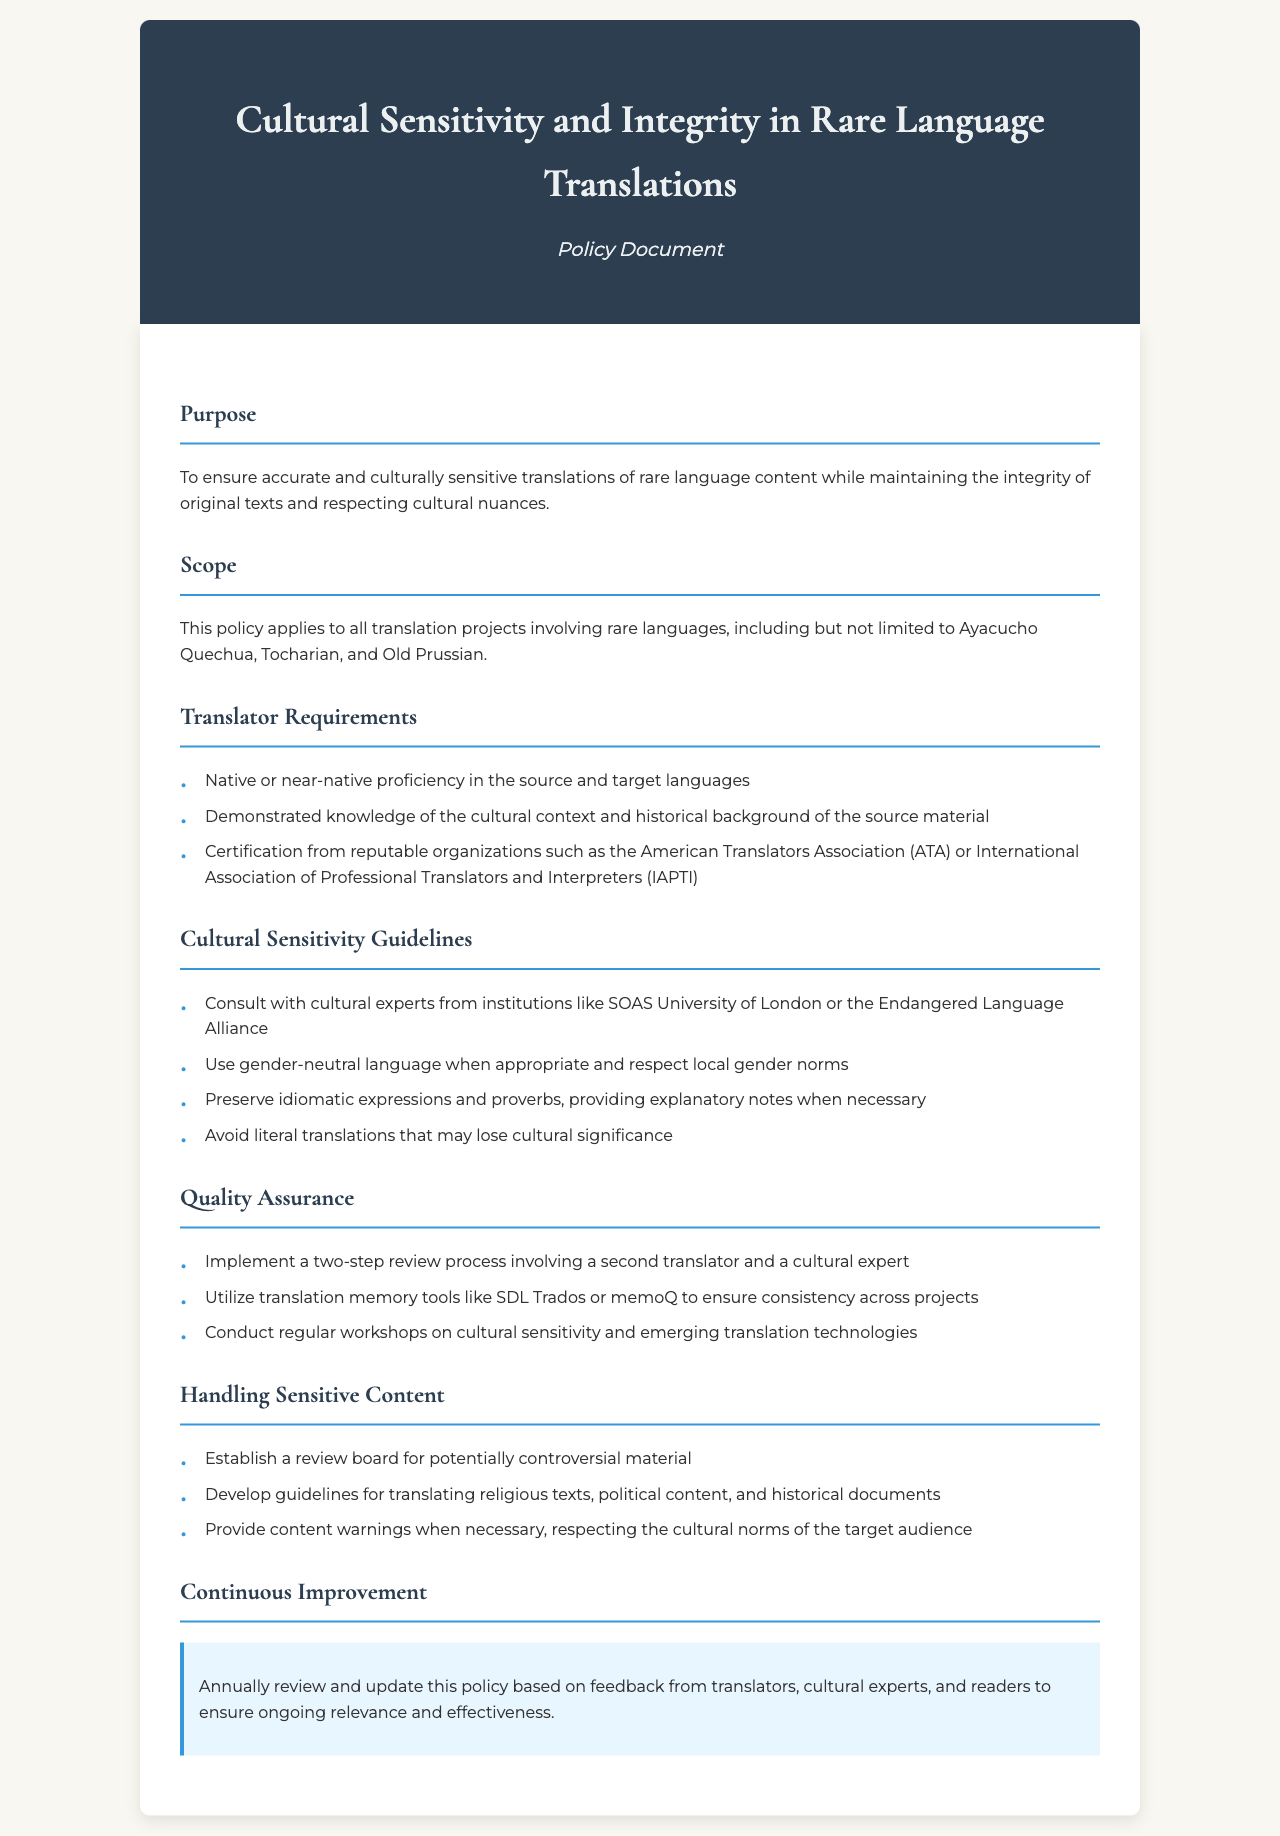What is the purpose of the policy? The purpose is to ensure accurate and culturally sensitive translations of rare language content while maintaining the integrity of original texts and respecting cultural nuances.
Answer: Ensuring accurate translations Which rare languages are mentioned in the scope? The scope mentions specific rare languages relevant to the policy, including Ayacucho Quechua, Tocharian, and Old Prussian.
Answer: Ayacucho Quechua, Tocharian, Old Prussian What type of proficiency is required for translators? The policy outlines a requirement for translators to have a certain level of language proficiency for effective translation.
Answer: Native or near-native proficiency What should translators consult for cultural sensitivity? The document specifies consulting specific institutions or experts to enhance understanding of cultural contexts.
Answer: Cultural experts How many steps are in the quality assurance process? The policy describes a review process composed of multiple steps to ensure high-quality translations.
Answer: Two-step What is a guideline for handling sensitive content? A guideline listed in the document addresses the consideration of various types of sensitive material in translations.
Answer: Establish a review board What is required annually for the policy? The document highlights an ongoing process for reviewing and updating the policy based on certain feedback.
Answer: Review and update What type of language should be used when appropriate? The guidelines in the document advocate for the use of specific language types that respect cultural nuances.
Answer: Gender-neutral language 